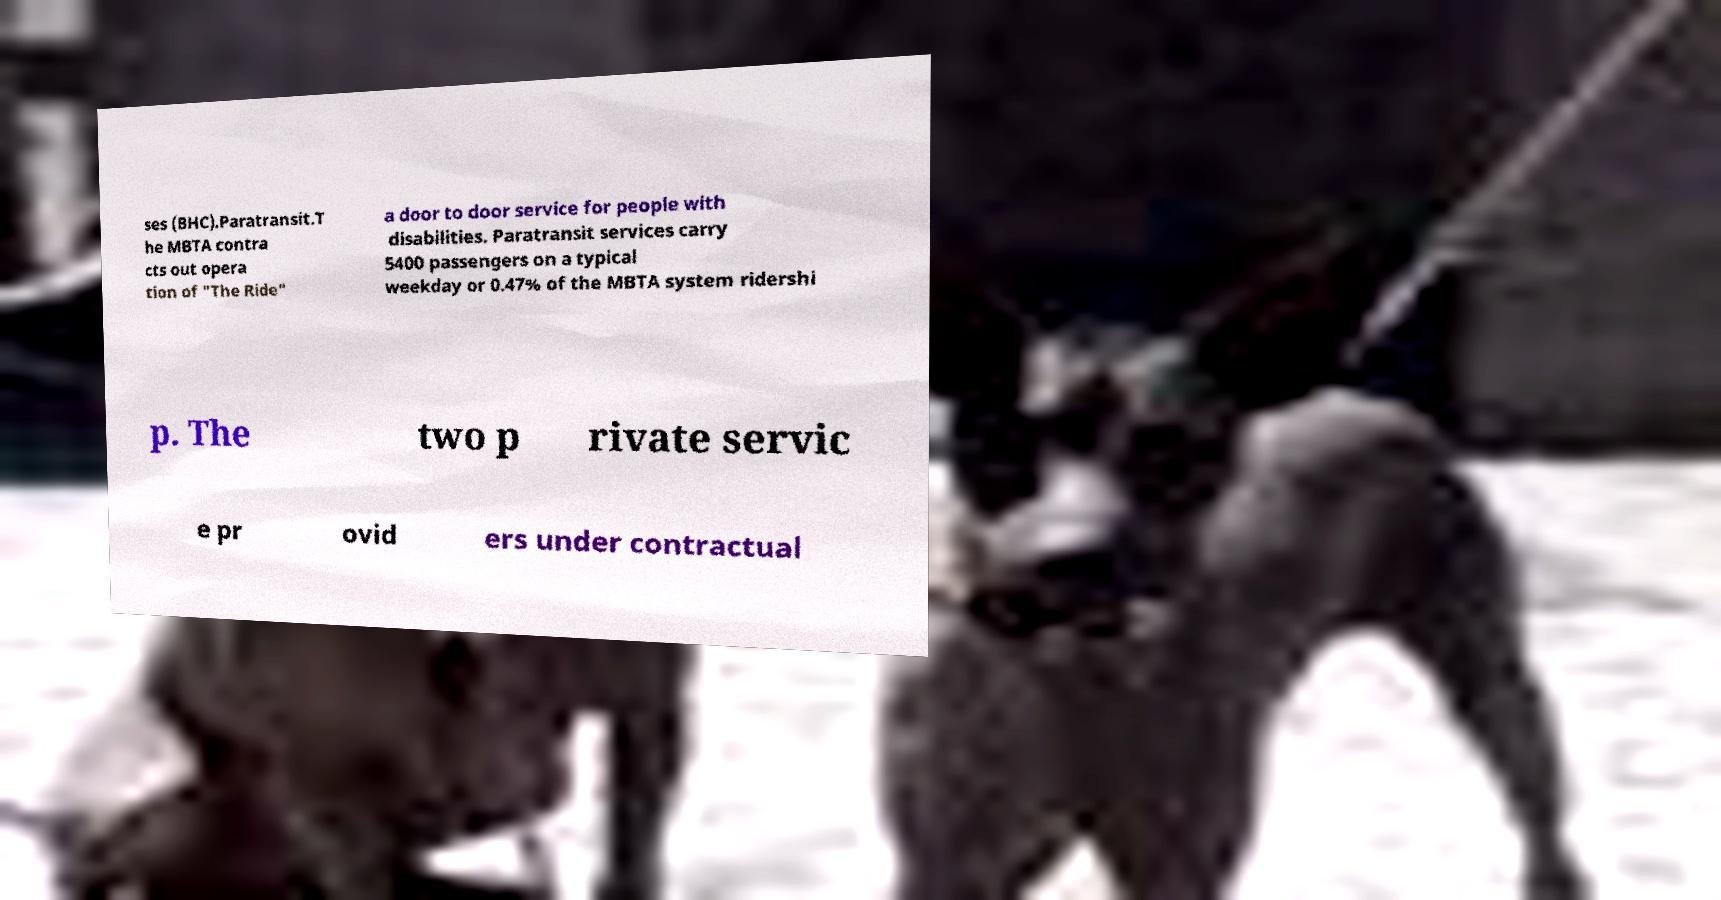Please identify and transcribe the text found in this image. ses (BHC).Paratransit.T he MBTA contra cts out opera tion of "The Ride" a door to door service for people with disabilities. Paratransit services carry 5400 passengers on a typical weekday or 0.47% of the MBTA system ridershi p. The two p rivate servic e pr ovid ers under contractual 